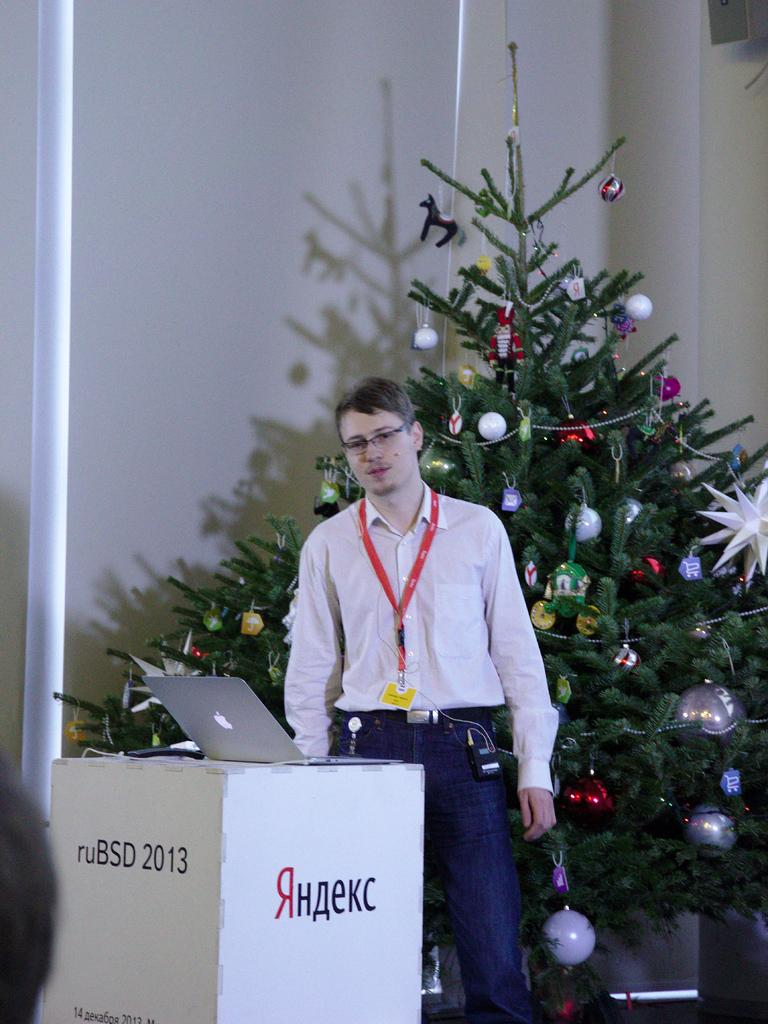<image>
Give a short and clear explanation of the subsequent image. A man standing in front of a Christmas tree behind a podium about a Russian computer service. 